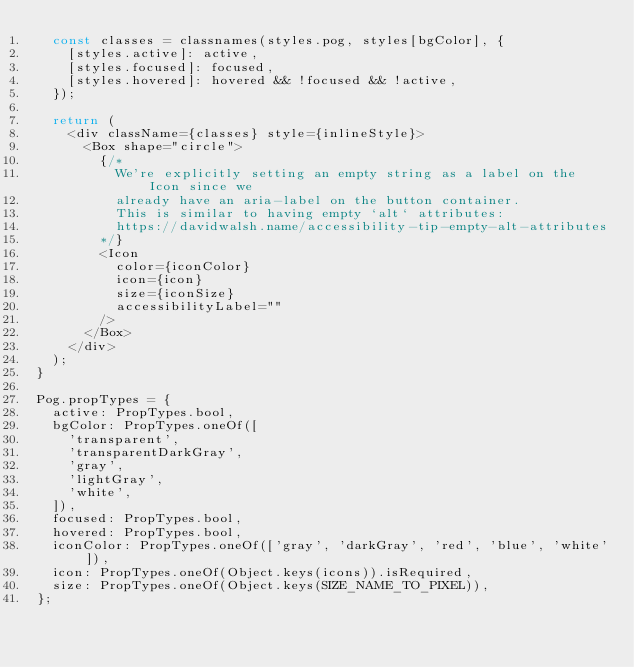Convert code to text. <code><loc_0><loc_0><loc_500><loc_500><_JavaScript_>  const classes = classnames(styles.pog, styles[bgColor], {
    [styles.active]: active,
    [styles.focused]: focused,
    [styles.hovered]: hovered && !focused && !active,
  });

  return (
    <div className={classes} style={inlineStyle}>
      <Box shape="circle">
        {/*
          We're explicitly setting an empty string as a label on the Icon since we
          already have an aria-label on the button container.
          This is similar to having empty `alt` attributes:
          https://davidwalsh.name/accessibility-tip-empty-alt-attributes
        */}
        <Icon
          color={iconColor}
          icon={icon}
          size={iconSize}
          accessibilityLabel=""
        />
      </Box>
    </div>
  );
}

Pog.propTypes = {
  active: PropTypes.bool,
  bgColor: PropTypes.oneOf([
    'transparent',
    'transparentDarkGray',
    'gray',
    'lightGray',
    'white',
  ]),
  focused: PropTypes.bool,
  hovered: PropTypes.bool,
  iconColor: PropTypes.oneOf(['gray', 'darkGray', 'red', 'blue', 'white']),
  icon: PropTypes.oneOf(Object.keys(icons)).isRequired,
  size: PropTypes.oneOf(Object.keys(SIZE_NAME_TO_PIXEL)),
};</code> 